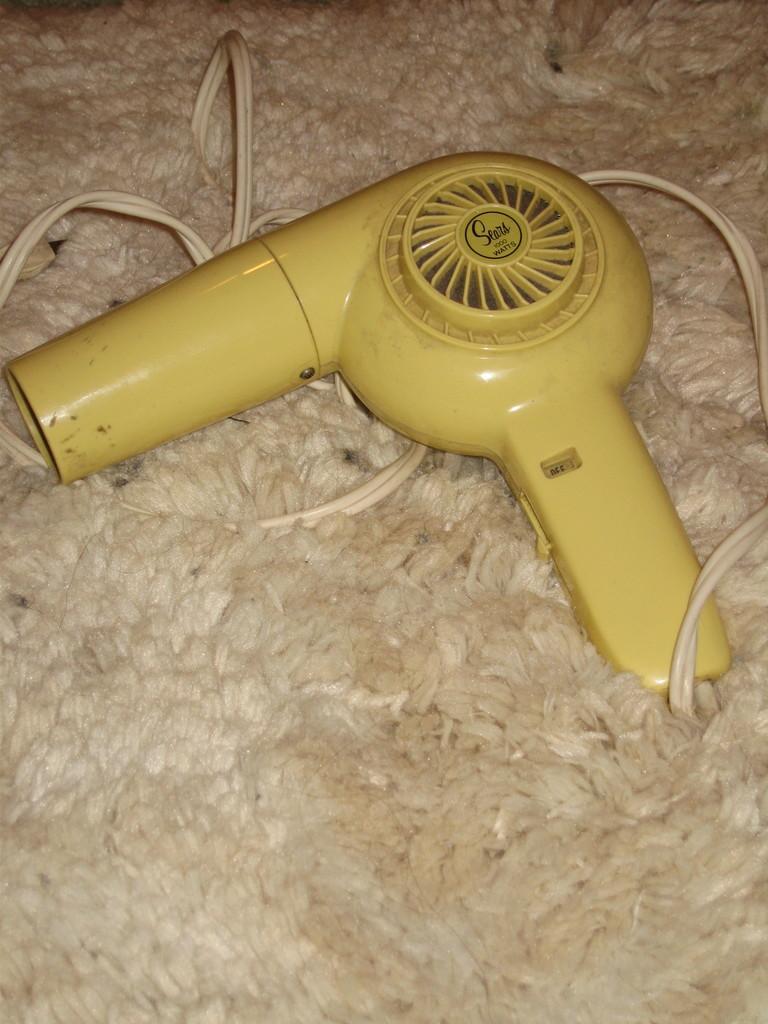Could you give a brief overview of what you see in this image? In the picture we can see a mat on it, we can see a hair dryer machine with a wire which is white in color and the machine is yellow in color. 